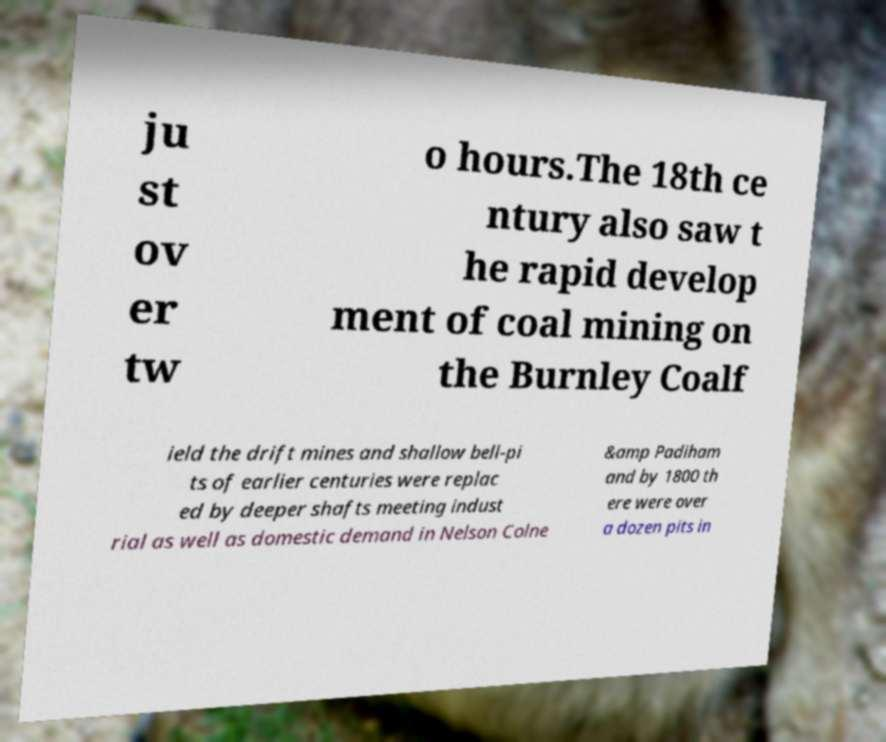Could you extract and type out the text from this image? ju st ov er tw o hours.The 18th ce ntury also saw t he rapid develop ment of coal mining on the Burnley Coalf ield the drift mines and shallow bell-pi ts of earlier centuries were replac ed by deeper shafts meeting indust rial as well as domestic demand in Nelson Colne &amp Padiham and by 1800 th ere were over a dozen pits in 